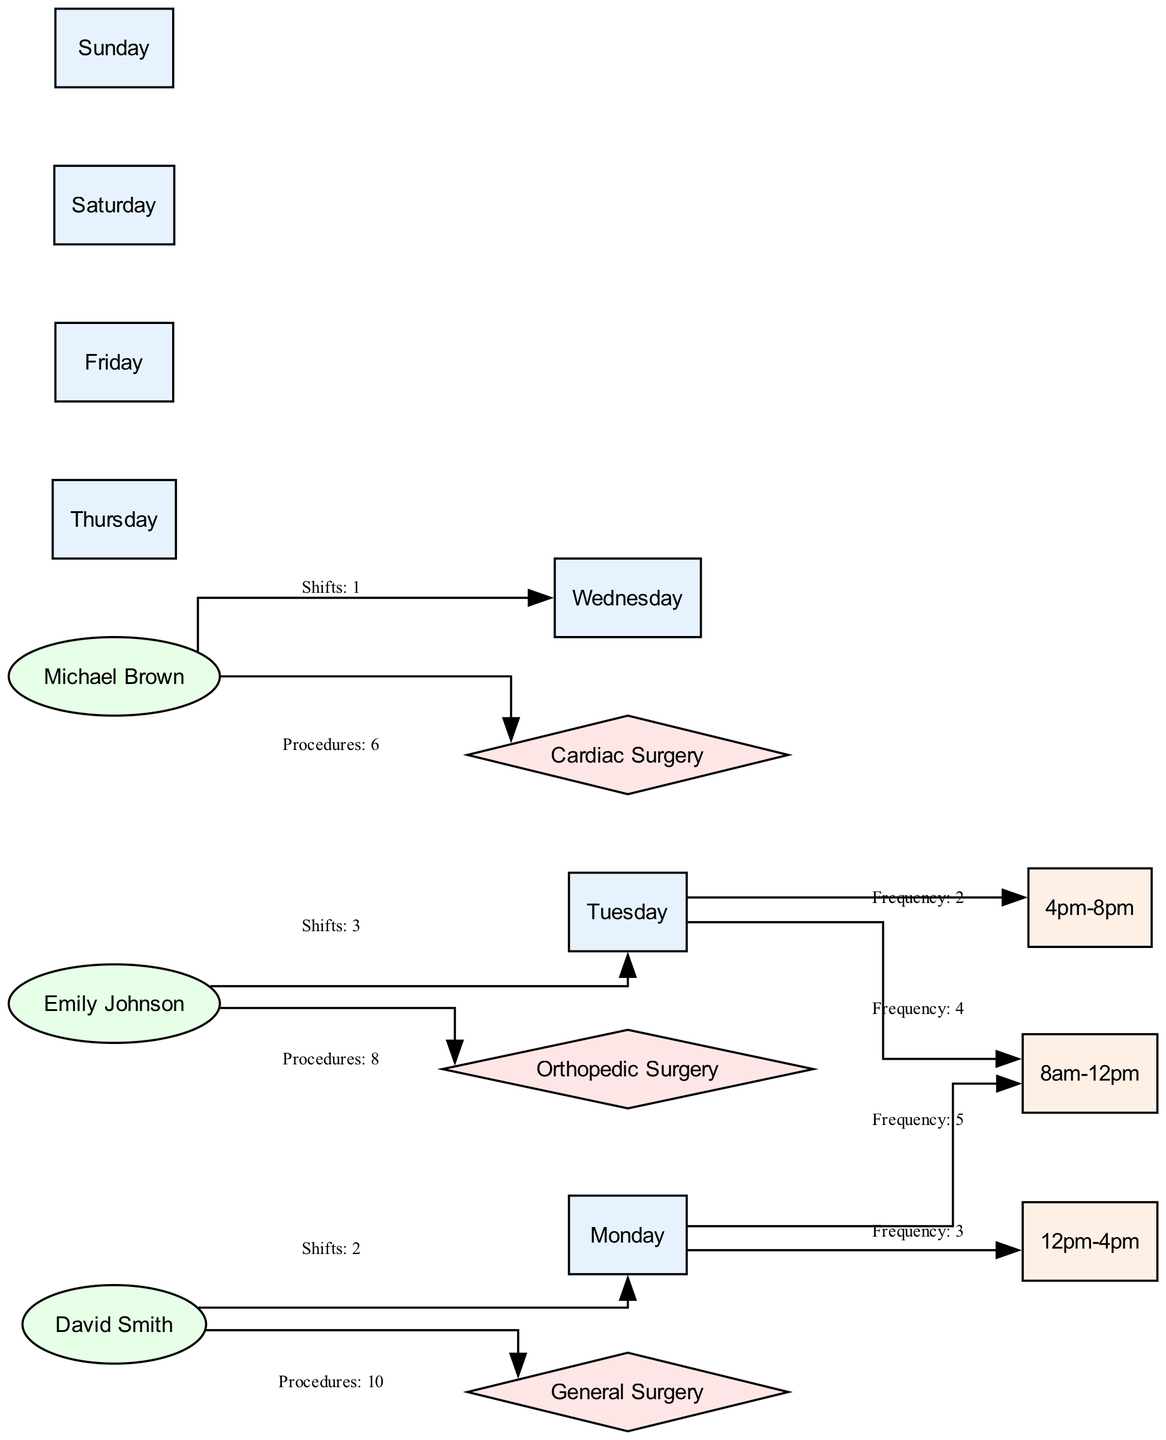What day has the highest frequency of procedures in the morning? Looking at the edges connected to the "8am-12pm" time slot, Monday has a frequency of 5, which is the highest compared to other days.
Answer: Monday How many total procedures does David Smith manage? The edge connecting David Smith and General Surgery shows he managed 10 procedures. Therefore, he has a total of 10 procedures.
Answer: 10 Which anesthesiologist works the most shifts? By reviewing the shifts, Emily Johnson has 3 shifts on Tuesday, which is the highest number of shifts among all the anesthesiologists listed.
Answer: Emily Johnson What procedure is associated with the least number for Michael Brown? Michael Brown's edge shows that he managed 6 procedures related to Cardiac Surgery, which is the only procedure listed for him, confirming it is the least since no other procedures are counted.
Answer: Cardiac Surgery How many edges are connected to Saturday? The diagram does not have any edges connected to the Saturday node, meaning there are no procedures or shifts for that day.
Answer: 0 What time slot has the lowest frequency on Tuesday? The edge shows that on Tuesday, the "4pm-8pm" time slot has a frequency of 2, which is lower than any other frequency recorded.
Answer: 4pm-8pm Which day does Michael Brown work? The edge indicates that Michael Brown has a shift on Wednesday, as shown by the edge linking him to the Wednesday node.
Answer: Wednesday What is the relationship between David Smith and General Surgery? The edge shows David Smith performing a total of 10 procedures categorized as General Surgery, establishing a direct link between David Smith and this procedure.
Answer: Procedures: 10 